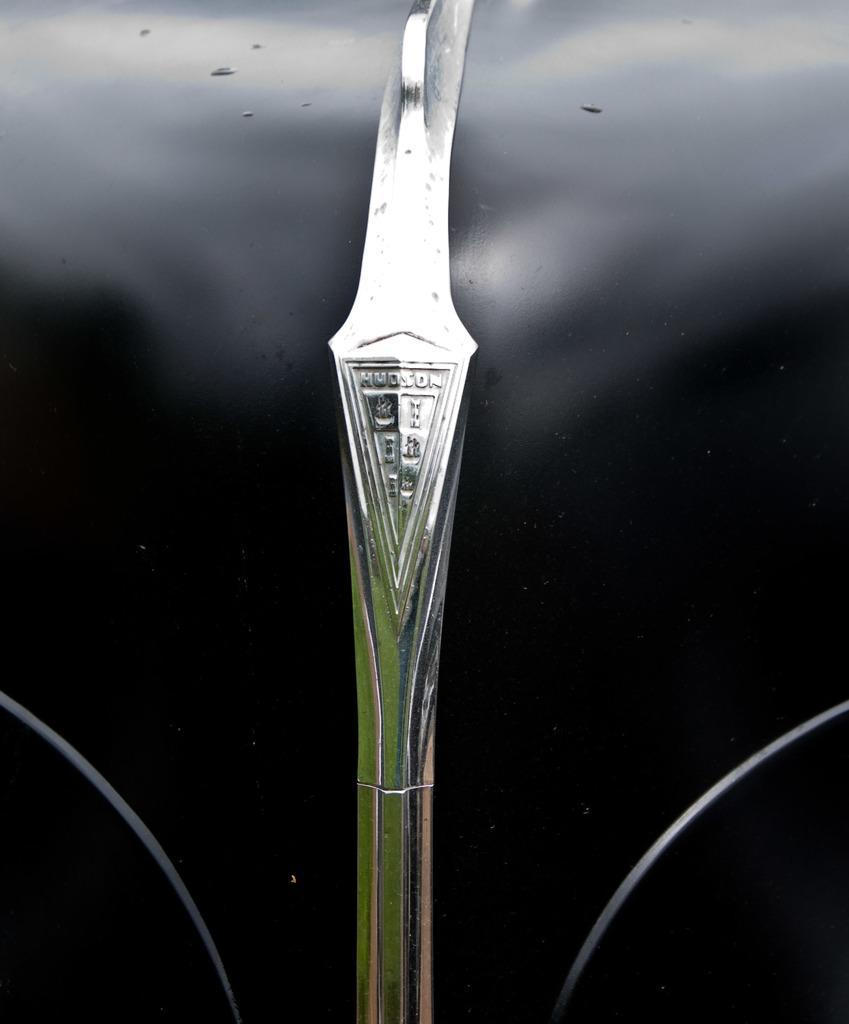Could you give a brief overview of what you see in this image? There is a black surface. On that there is a silver thing with something written on that. 